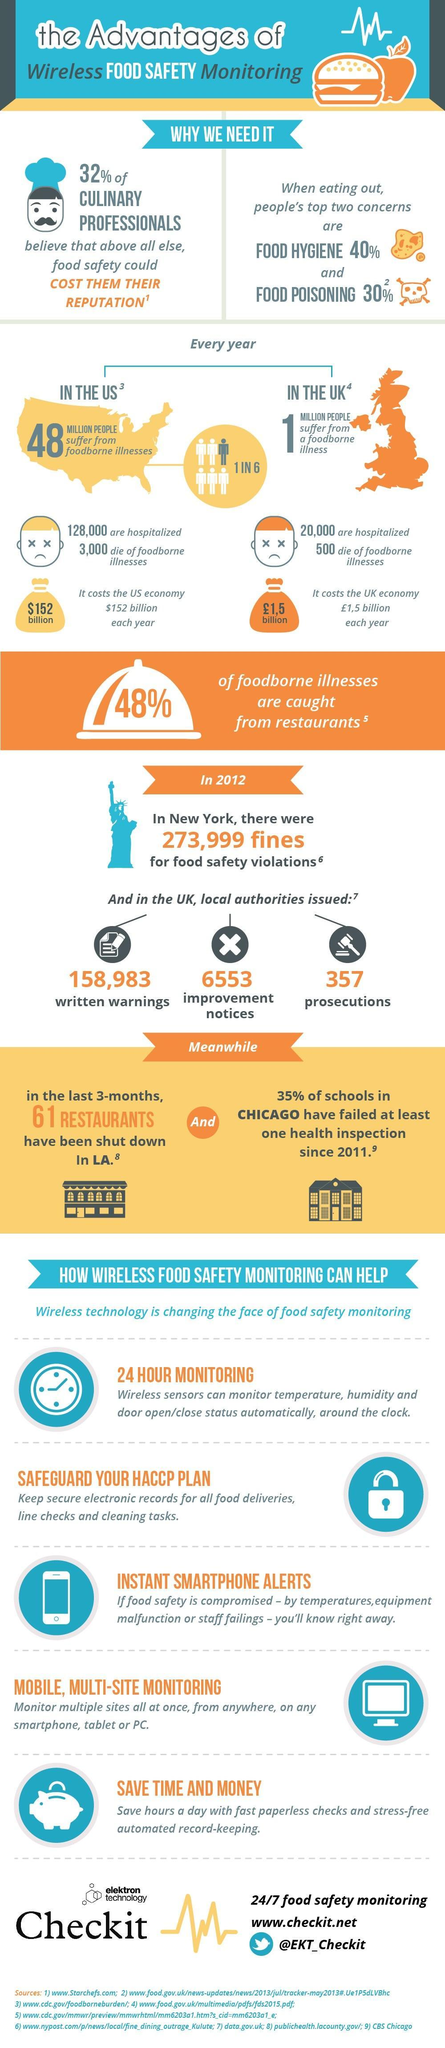What is the ratio of people suffering from foodborne diseases in the US each year?
Answer the question with a short phrase. 1 in 6 Which two factors are people concerned about while eating out? food hygiene, food poisoning In which country are 128,000 people hospitalized each year due to food related diseases? US In which country was 357 prosecutions issued for food safety violations? UK How many deaths are caused due to foodborne illnesses in US each year? 3,000 In which country are 20,000 people hospitalized each year due to food related diseases? UK How many deaths are caused due to foodborne illnesses in UK each year? 500 In which US state 61 restaurants were closed in 3-months for failing health inspections? LA How many improvement notices were issued in the UK in 2012? 6553 How many written warnings were issued in the UK in 2012? 158,983 